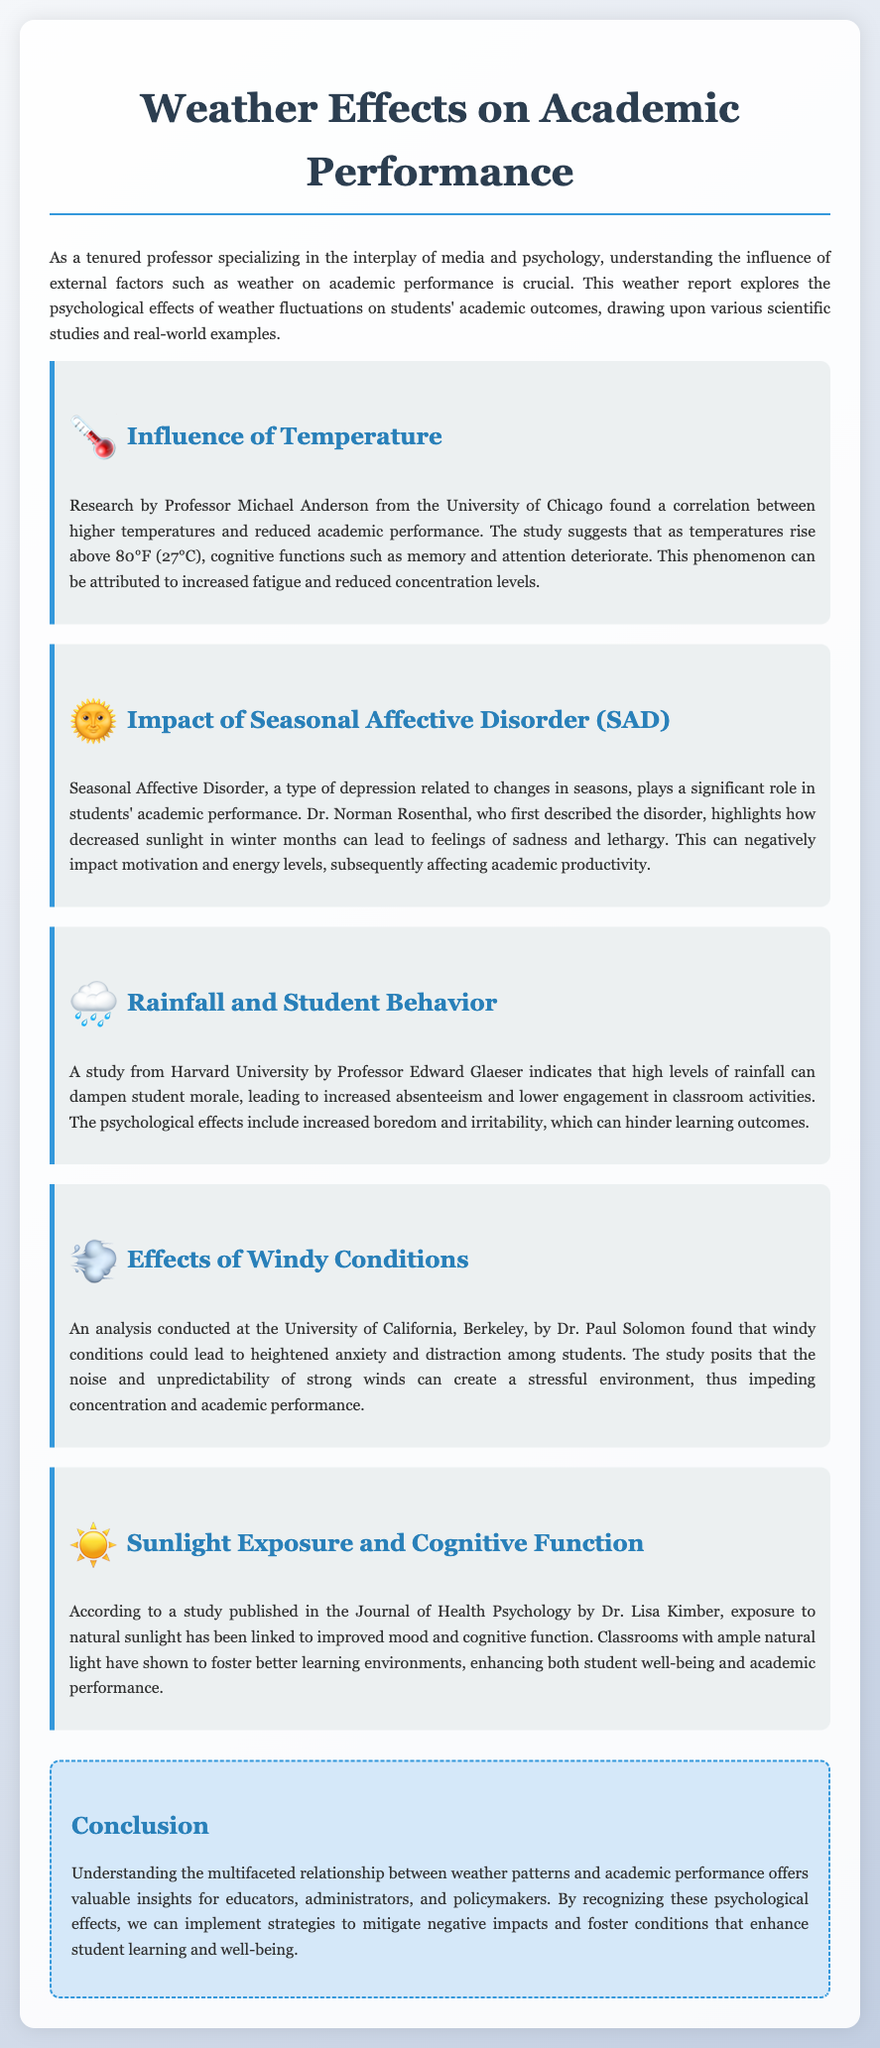What is the temperature threshold identified by the study for cognitive function deterioration? The study suggests that cognitive functions deteriorate when temperatures rise above 80°F (27°C).
Answer: 80°F Who conducted the research on Seasonal Affective Disorder? Dr. Norman Rosenthal is the researcher who highlights the impact of Seasonal Affective Disorder on academic performance.
Answer: Dr. Norman Rosenthal What psychological effect is linked to high levels of rainfall? The psychological effect linked to high levels of rainfall includes increased boredom and irritability.
Answer: Increased boredom and irritability Which university did Dr. Paul Solomon represent in his analysis of windy conditions? Dr. Paul Solomon conducted his analysis at the University of California, Berkeley.
Answer: University of California, Berkeley What benefit does exposure to natural sunlight provide according to Dr. Lisa Kimber's study? Dr. Lisa Kimber's study states that exposure to natural sunlight is linked to improved mood and cognitive function.
Answer: Improved mood and cognitive function What is the main focus of the report? The report focuses on the psychological effects of weather fluctuations on academic performance.
Answer: Psychological effects of weather fluctuations on academic performance Which classroom condition is mentioned as fostering better learning environments? Classrooms with ample natural light are mentioned as fostering better learning environments.
Answer: Ample natural light What type of report is this document? The document is a weather report exploring the influence of weather on academic performance.
Answer: Weather report 